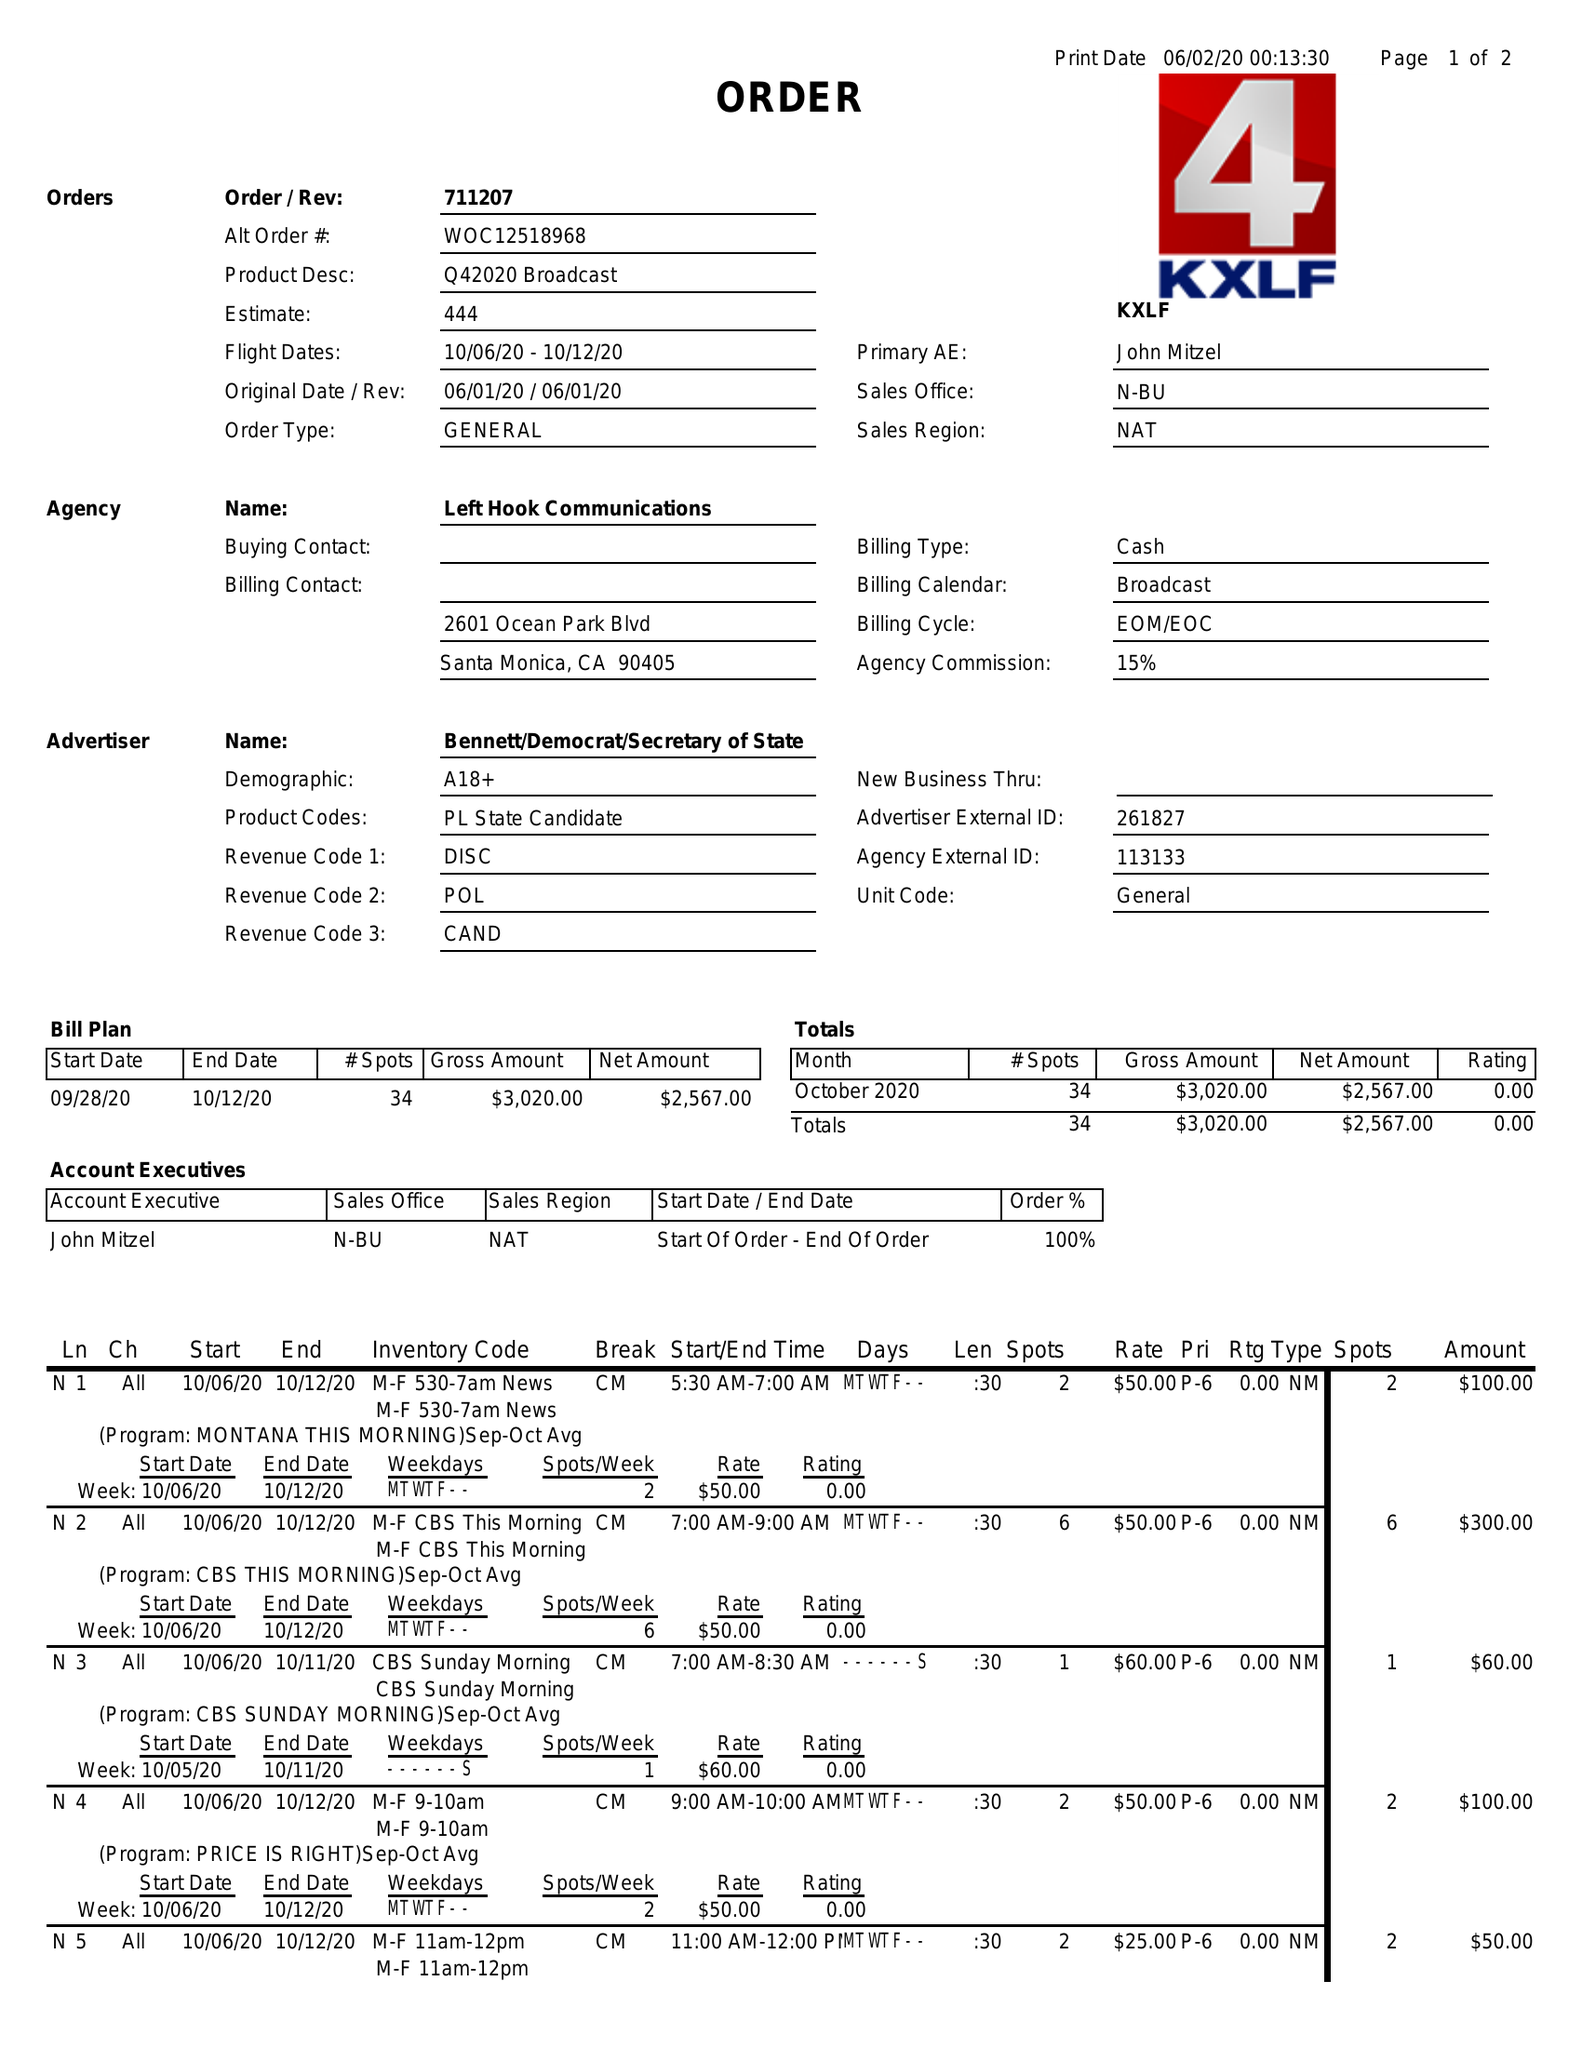What is the value for the advertiser?
Answer the question using a single word or phrase. BENNETT/DEMOCRAT/SECRETARYOFSTATE 